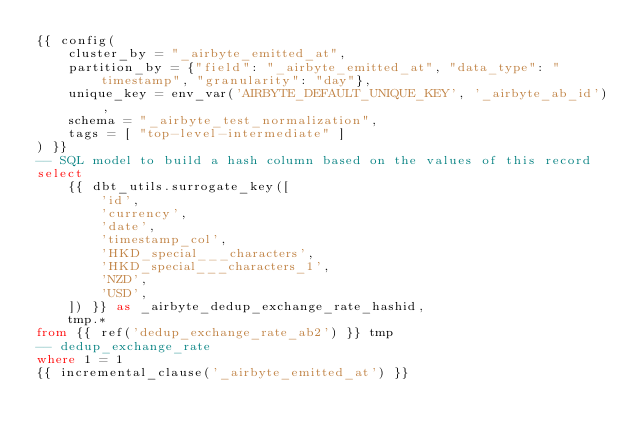<code> <loc_0><loc_0><loc_500><loc_500><_SQL_>{{ config(
    cluster_by = "_airbyte_emitted_at",
    partition_by = {"field": "_airbyte_emitted_at", "data_type": "timestamp", "granularity": "day"},
    unique_key = env_var('AIRBYTE_DEFAULT_UNIQUE_KEY', '_airbyte_ab_id'),
    schema = "_airbyte_test_normalization",
    tags = [ "top-level-intermediate" ]
) }}
-- SQL model to build a hash column based on the values of this record
select
    {{ dbt_utils.surrogate_key([
        'id',
        'currency',
        'date',
        'timestamp_col',
        'HKD_special___characters',
        'HKD_special___characters_1',
        'NZD',
        'USD',
    ]) }} as _airbyte_dedup_exchange_rate_hashid,
    tmp.*
from {{ ref('dedup_exchange_rate_ab2') }} tmp
-- dedup_exchange_rate
where 1 = 1
{{ incremental_clause('_airbyte_emitted_at') }}

</code> 